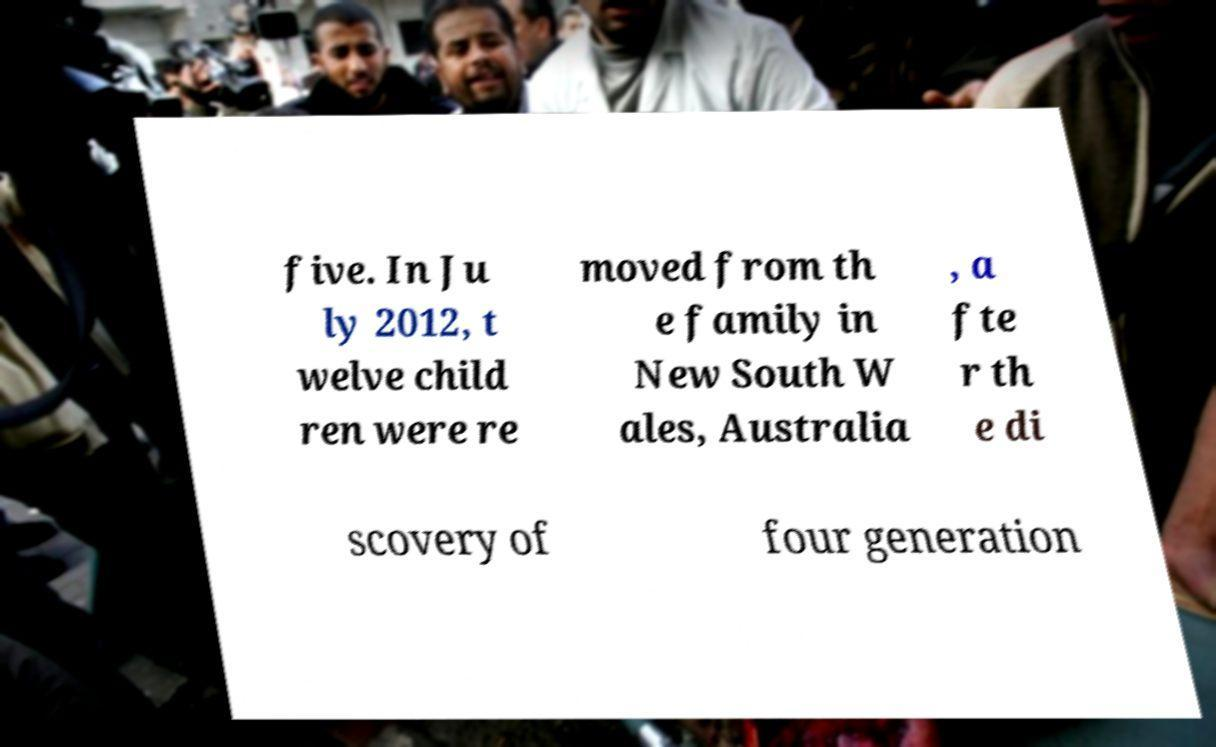I need the written content from this picture converted into text. Can you do that? five. In Ju ly 2012, t welve child ren were re moved from th e family in New South W ales, Australia , a fte r th e di scovery of four generation 